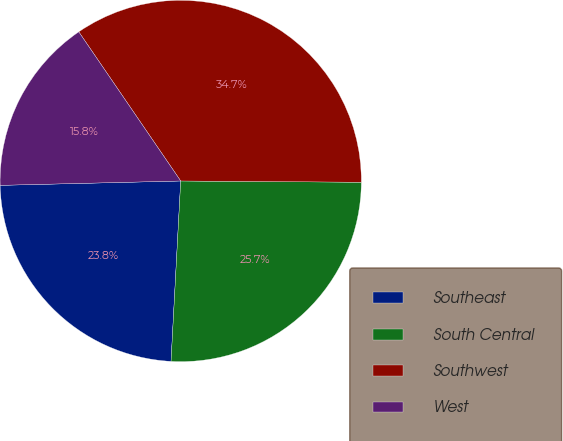Convert chart to OTSL. <chart><loc_0><loc_0><loc_500><loc_500><pie_chart><fcel>Southeast<fcel>South Central<fcel>Southwest<fcel>West<nl><fcel>23.76%<fcel>25.74%<fcel>34.65%<fcel>15.84%<nl></chart> 